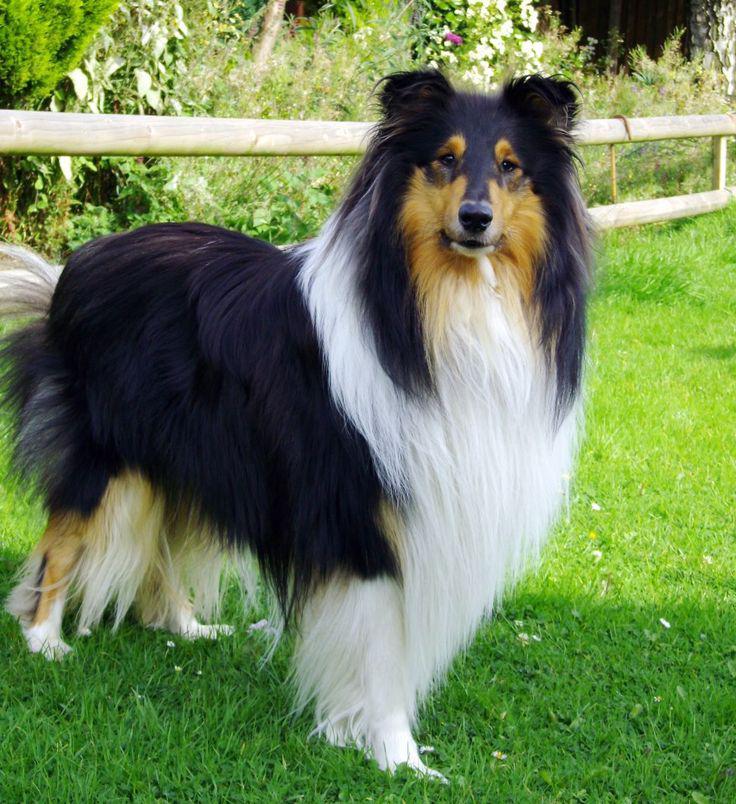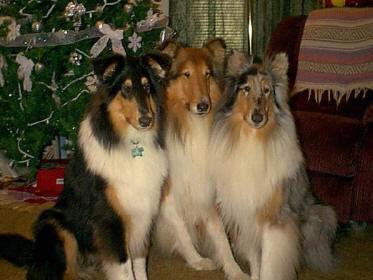The first image is the image on the left, the second image is the image on the right. Given the left and right images, does the statement "One image depicts exactly three collies standing in a row, each with a different fur coloring pattern." hold true? Answer yes or no. No. The first image is the image on the left, the second image is the image on the right. Given the left and right images, does the statement "There are 4 dogs total" hold true? Answer yes or no. Yes. 